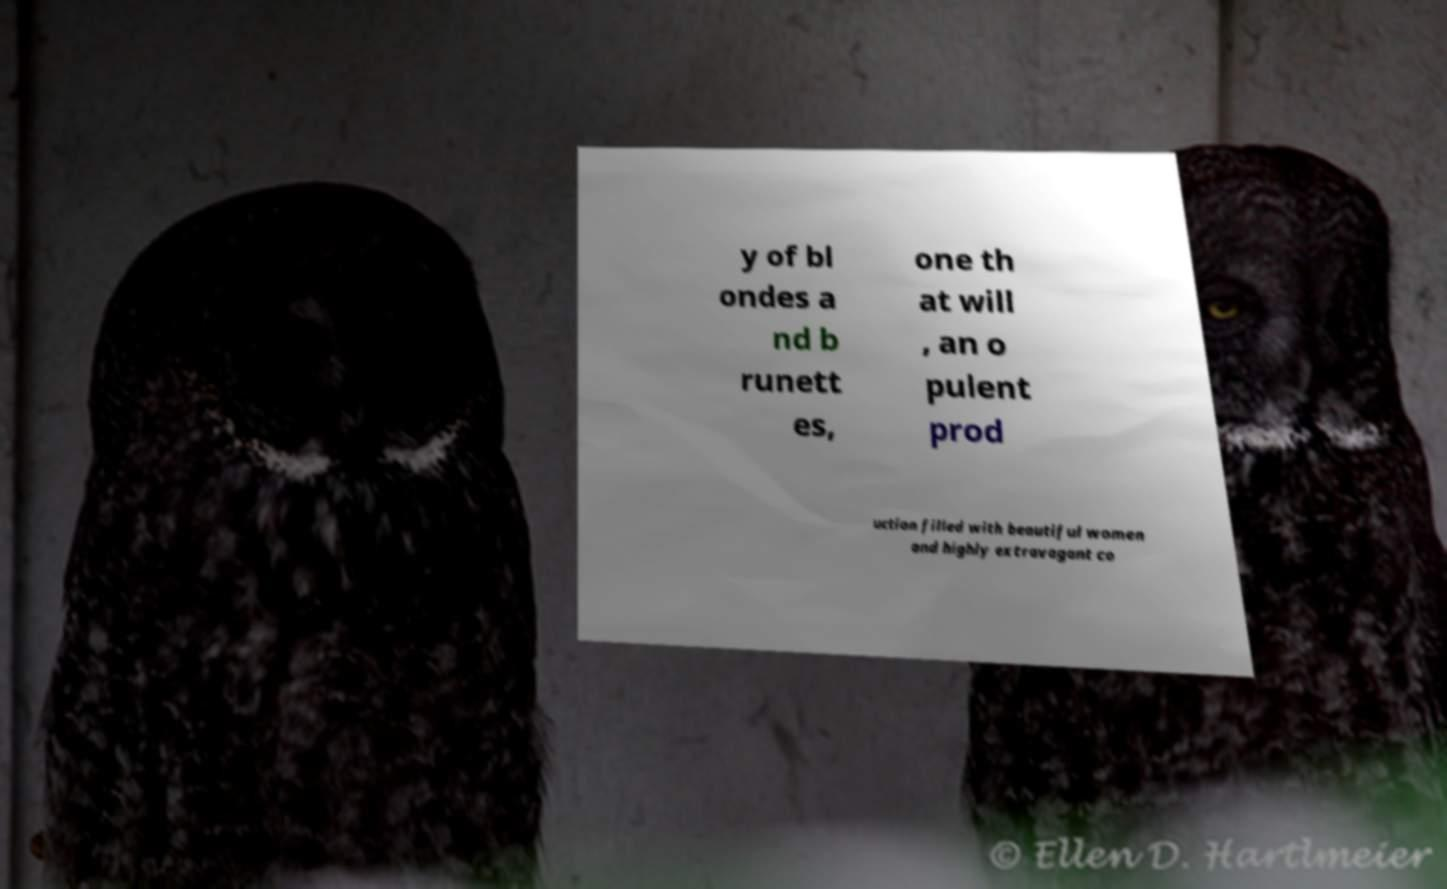Could you assist in decoding the text presented in this image and type it out clearly? y of bl ondes a nd b runett es, one th at will , an o pulent prod uction filled with beautiful women and highly extravagant co 